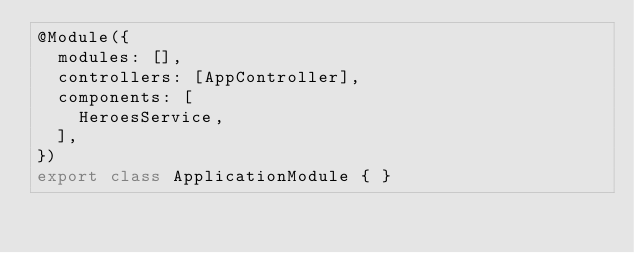Convert code to text. <code><loc_0><loc_0><loc_500><loc_500><_TypeScript_>@Module({
  modules: [],
  controllers: [AppController],
  components: [
    HeroesService,
  ],
})
export class ApplicationModule { }
</code> 